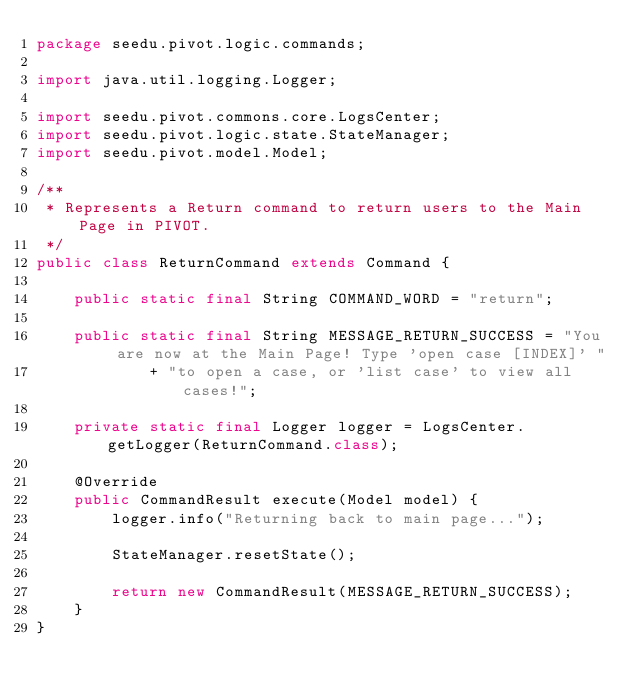<code> <loc_0><loc_0><loc_500><loc_500><_Java_>package seedu.pivot.logic.commands;

import java.util.logging.Logger;

import seedu.pivot.commons.core.LogsCenter;
import seedu.pivot.logic.state.StateManager;
import seedu.pivot.model.Model;

/**
 * Represents a Return command to return users to the Main Page in PIVOT.
 */
public class ReturnCommand extends Command {

    public static final String COMMAND_WORD = "return";

    public static final String MESSAGE_RETURN_SUCCESS = "You are now at the Main Page! Type 'open case [INDEX]' "
            + "to open a case, or 'list case' to view all cases!";

    private static final Logger logger = LogsCenter.getLogger(ReturnCommand.class);

    @Override
    public CommandResult execute(Model model) {
        logger.info("Returning back to main page...");

        StateManager.resetState();

        return new CommandResult(MESSAGE_RETURN_SUCCESS);
    }
}
</code> 